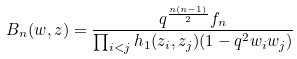<formula> <loc_0><loc_0><loc_500><loc_500>B _ { n } ( w , z ) = \frac { q ^ { \frac { n ( n - 1 ) } { 2 } } f _ { n } } { \prod _ { i < j } h _ { 1 } ( z _ { i } , z _ { j } ) ( 1 - q ^ { 2 } w _ { i } w _ { j } ) }</formula> 